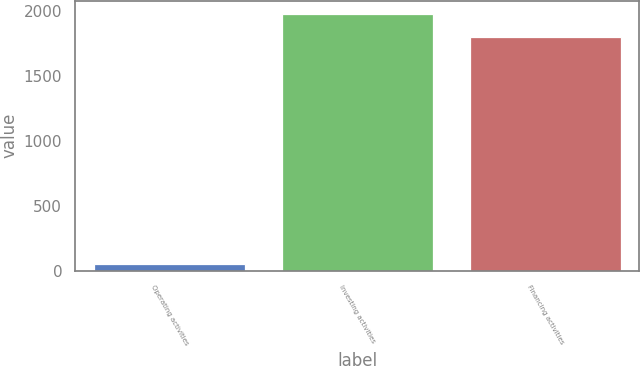Convert chart to OTSL. <chart><loc_0><loc_0><loc_500><loc_500><bar_chart><fcel>Operating activities<fcel>Investing activities<fcel>Financing activities<nl><fcel>53.7<fcel>1976.94<fcel>1799.5<nl></chart> 